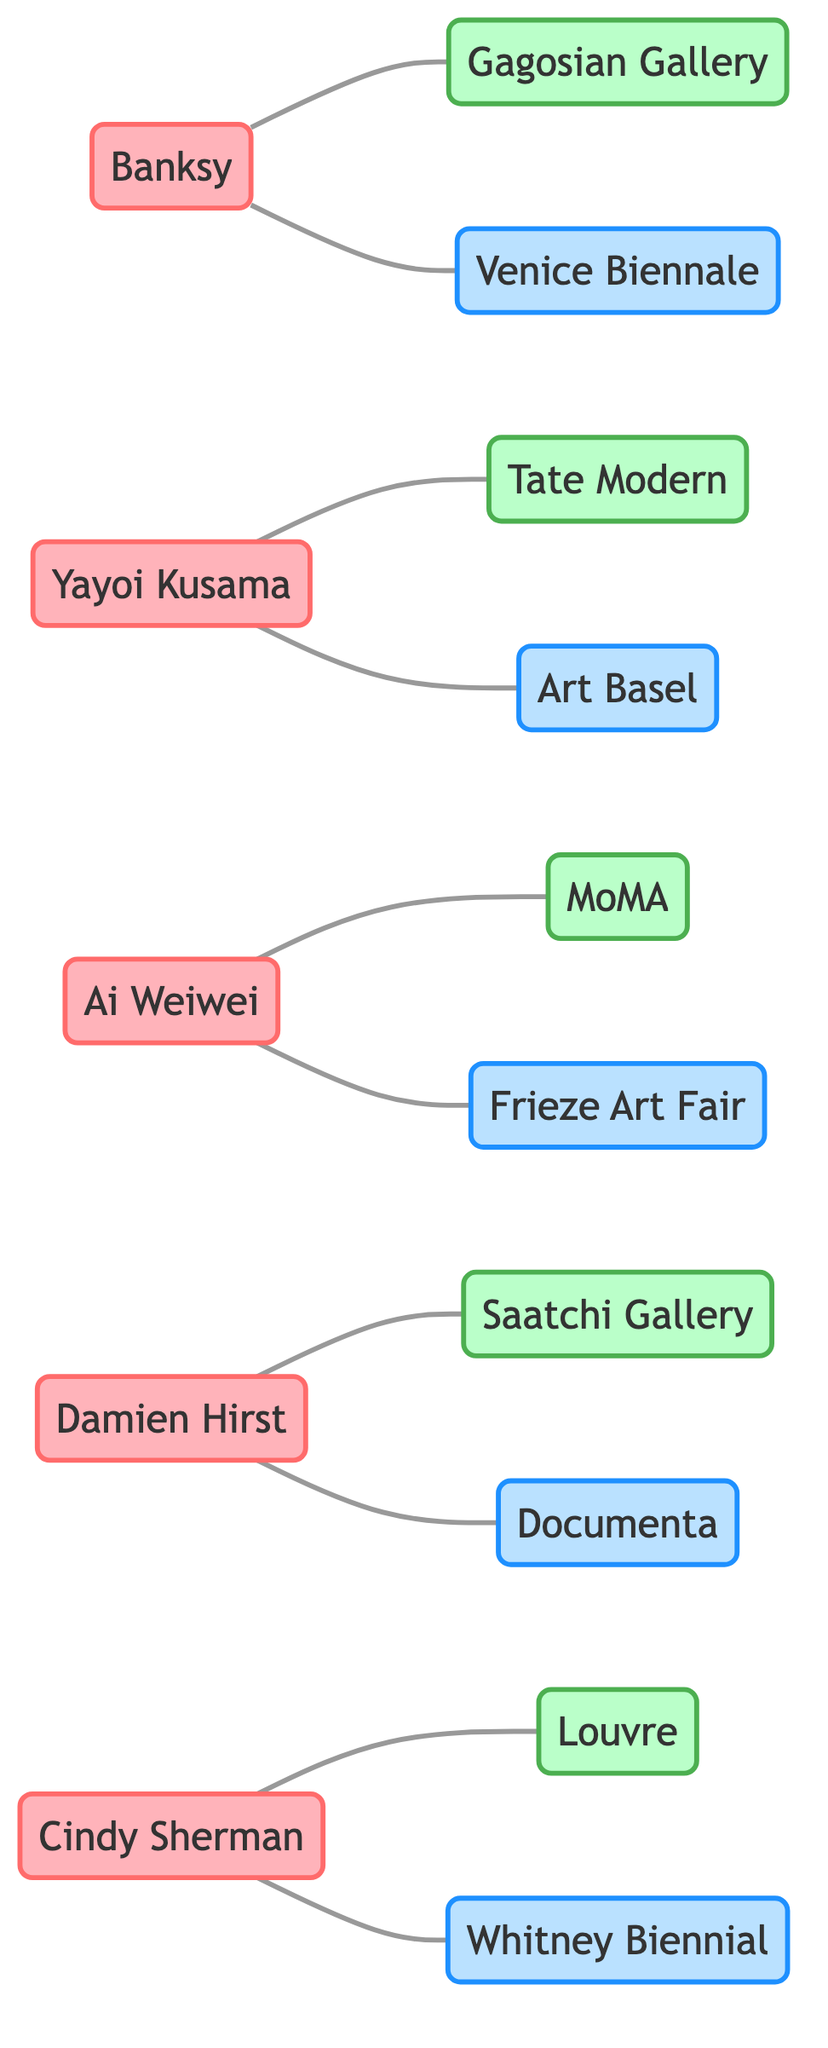What is the total number of artists represented in the diagram? There are five distinct artists listed in the diagram: Banksy, Yayoi Kusama, Ai Weiwei, Damien Hirst, and Cindy Sherman. Counting these names gives us 5.
Answer: 5 Which gallery is connected to Banksy? The diagram shows a direct line between Banksy and Gagosian Gallery, indicating a collaboration relationship. Therefore, Gagosian Gallery is the gallery connected to Banksy.
Answer: Gagosian Gallery How many art events are represented in the diagram? The diagram lists five art events: Venice Biennale, Art Basel, Frieze Art Fair, Documenta, and Whitney Biennial. Counting these events results in 5.
Answer: 5 Which artist is connected to the Saatchi Gallery? Looking at the diagram, we can see a direct connection between Damien Hirst and Saatchi Gallery. Thus, the artist connected to the Saatchi Gallery is Damien Hirst.
Answer: Damien Hirst Who collaborates with both Ai Weiwei and the Frieze Art Fair? Ai Weiwei is specifically mentioned to collaborate with the Frieze Art Fair in the diagram, but there are no other artists or entities linked to both Ai Weiwei and Frieze in this instance, leading to the conclusion that Ai Weiwei is the only artist linked to the Frieze Art Fair through the diagram.
Answer: Ai Weiwei Which artist has collaborations with both galleries and art events? The diagram indicates that all five artists have at least one connection to both galleries and art events. For instance, Banksy collaborates with Gagosian Gallery and Venice Biennale, demonstrating this dual collaboration.
Answer: Banksy What is the relationship type between Yayoi Kusama and the Tate Modern? In the diagram, Yayoi Kusama is connected to Tate Modern with a direct line, representing a collaborative relationship between the artist and the gallery. Thus, the relationship type here is a collaboration.
Answer: Collaboration How many unique connections does Cindy Sherman have in the diagram? The diagram shows that Cindy Sherman is connected to two nodes: Louvre and Whitney Biennial. These are the unique connections for her, totaling two.
Answer: 2 